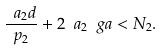<formula> <loc_0><loc_0><loc_500><loc_500>\frac { \ a _ { 2 } d } { p _ { 2 } } + 2 \ a _ { 2 } \ g a < N _ { 2 } .</formula> 